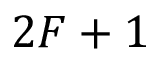Convert formula to latex. <formula><loc_0><loc_0><loc_500><loc_500>2 F + 1</formula> 